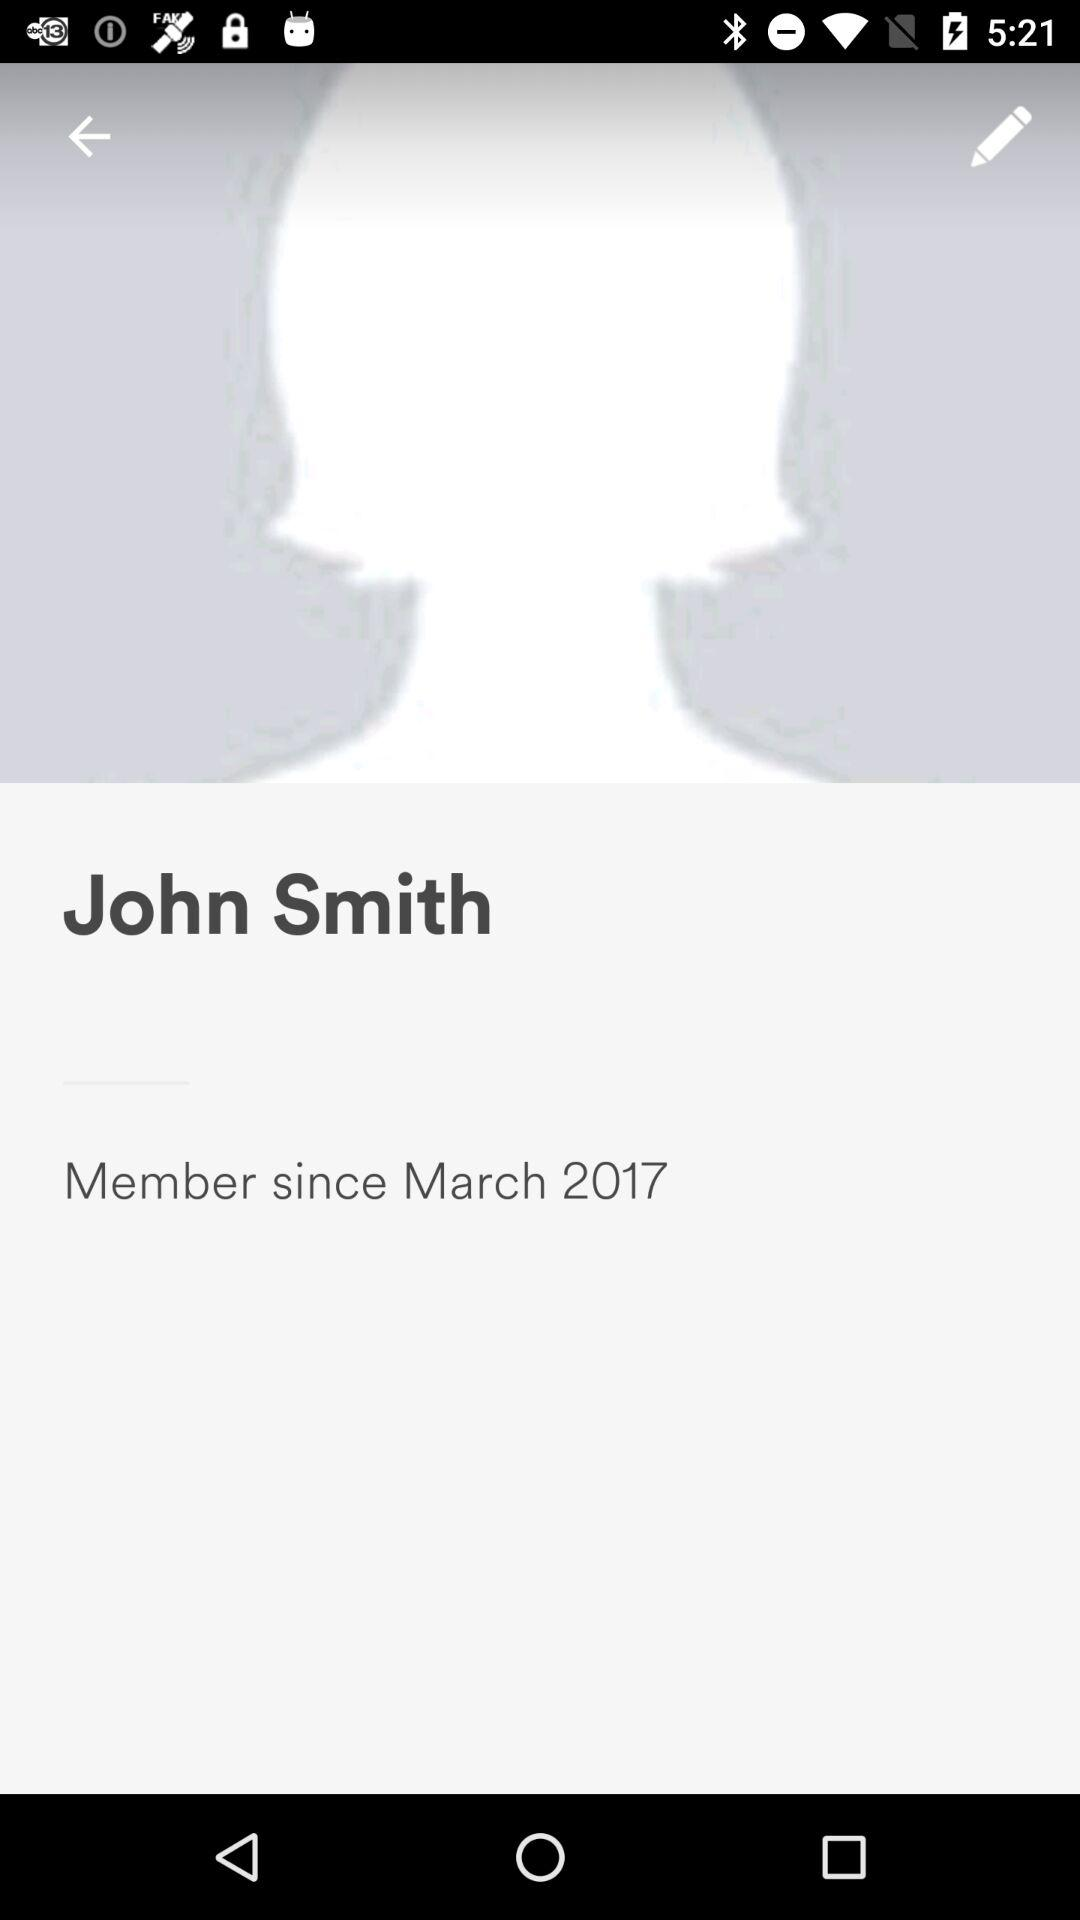What is the user name? The user name is John Smith. 